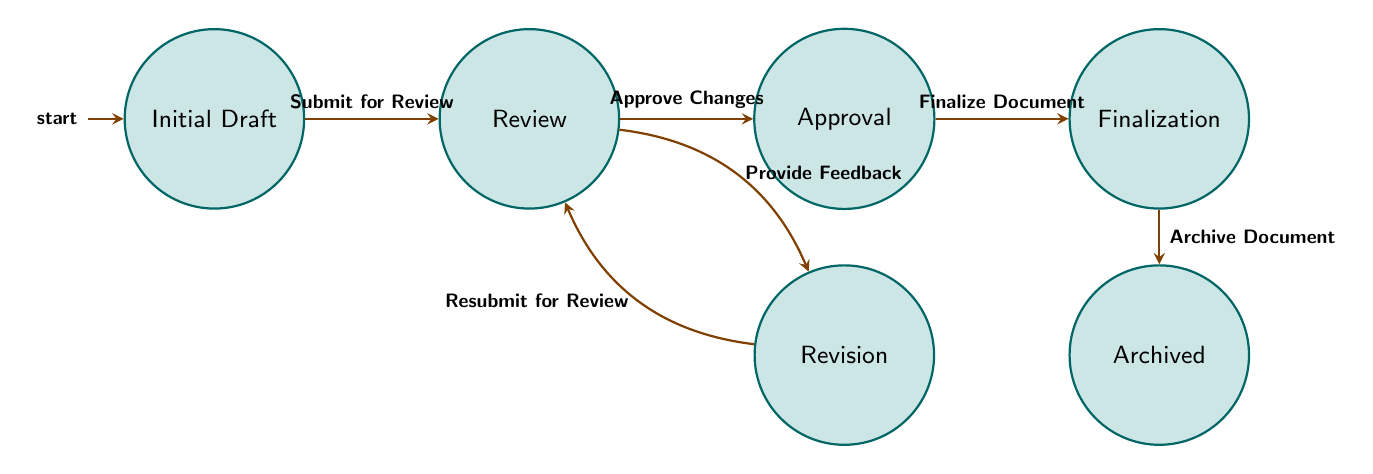What is the starting point in the document version control process? The starting point is represented by the first node in the diagram, which is labeled "Initial Draft." This is where the document creation begins.
Answer: Initial Draft How many states are present in the diagram? By counting the nodes (states) shown in the diagram, we find there are six distinct states representing different stages in the document version control process.
Answer: 6 What action transitions the state from 'Review' to 'Approval'? According to the edges in the diagram, the transition from 'Review' to 'Approval' occurs when the action "Approve Changes" is taken. This action represents obtaining the necessary approvals from collaborators.
Answer: Approve Changes What state follows 'Finalization'? The flow dictates that after the 'Finalization' state, the document moves to the 'Archived' state, indicating that it has been completed and stored for future reference.
Answer: Archived What is the action taken to move the document back to 'Review' from 'Revision'? The action that allows the document to transition back to 'Review' from 'Revision' is labeled "Resubmit for Review," representing the author's submission of revised content for further evaluation.
Answer: Resubmit for Review Which two states are directly connected with feedback interaction? The states involved in the feedback interaction are 'Review' and 'Revision.' The transition occurs when feedback is provided after the document is reviewed, prompting revisions by the user.
Answer: Review and Revision What is the final state of the document version control process? The diagram clearly indicates that the last state in the process is 'Archived,' implying that once finalized, the document is stored away as a record.
Answer: Archived What transition occurs after 'Revision' and before 'Approval'? The transition that occurs right after 'Revision' and prior to 'Approval' is the approval of changes which takes place in the 'Review' stage, leading to the approval after feedback has been addressed.
Answer: Approve Changes What does the action "Archive Document" signify in this process? The "Archive Document" action represents the final step in the process, indicating that the document is no longer active and has been stored for future reference after all necessary steps have been completed.
Answer: Archive Document 